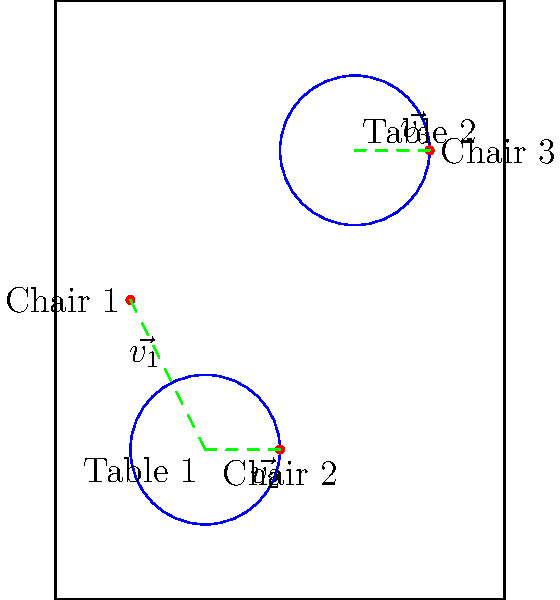In your art shop, you want to arrange two tables and three chairs for the best ambiance. The positions of the tables and chairs are represented by vectors from the origin. Table 1 is at $\vec{T_1} = (1,1)$, Table 2 is at $\vec{T_2} = (2,3)$, and the chairs are at $\vec{C_1} = (0.5,2)$, $\vec{C_2} = (1.5,1)$, and $\vec{C_3} = (2.5,3)$. To create the optimal arrangement, you need to minimize the total distance between the tables and their nearest chairs. Using vector addition, calculate the vector that represents the optimal placement of Chair 3 relative to Table 2. Let's approach this step-by-step:

1) We need to find the vector from Table 2 to Chair 3. This can be done by subtracting the position vector of Table 2 from the position vector of Chair 3.

2) The vector from Table 2 to Chair 3 is:
   $\vec{v_3} = \vec{C_3} - \vec{T_2}$

3) Let's calculate this:
   $\vec{v_3} = (2.5,3) - (2,3)$
   $\vec{v_3} = (0.5,0)$

4) This vector $\vec{v_3}$ represents the optimal placement of Chair 3 relative to Table 2, as it's already the shortest distance between them.

5) In vector notation, we can write this as:
   $\vec{v_3} = 0.5\hat{i} + 0\hat{j}$

Where $\hat{i}$ is the unit vector in the x-direction and $\hat{j}$ is the unit vector in the y-direction.
Answer: $(0.5,0)$ 